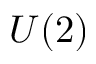<formula> <loc_0><loc_0><loc_500><loc_500>U ( 2 )</formula> 